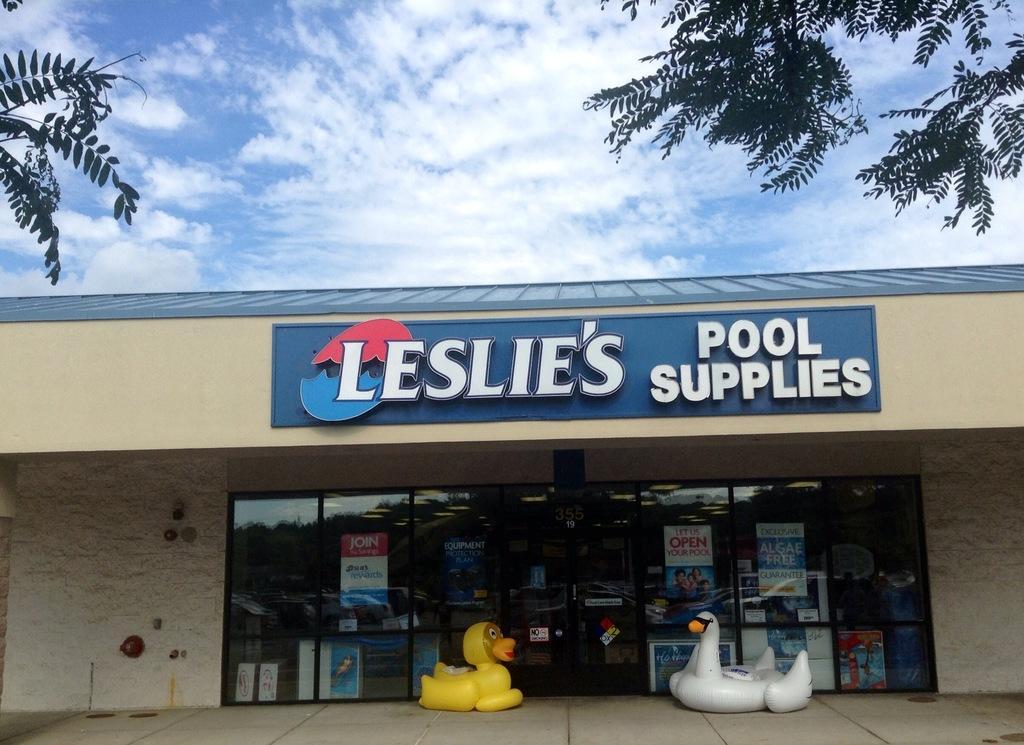Please provide a concise description of this image. In this picture we can see there are toys on the path and behind the toys there is a building and in front of the building there are trees. Behind the building there is a sky. 